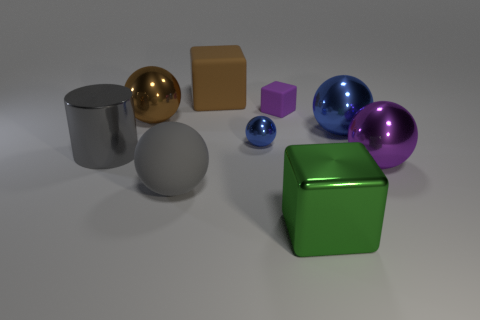What is the color of the block that is both to the right of the tiny blue object and behind the green block?
Keep it short and to the point. Purple. There is a purple rubber object; how many things are left of it?
Your response must be concise. 5. What material is the large brown block?
Offer a very short reply. Rubber. The small thing on the left side of the purple thing behind the big metallic thing that is on the left side of the brown metal sphere is what color?
Make the answer very short. Blue. How many gray balls are the same size as the brown rubber thing?
Keep it short and to the point. 1. What is the color of the tiny metal thing behind the cylinder?
Keep it short and to the point. Blue. How many other things are there of the same size as the gray cylinder?
Your answer should be compact. 6. What is the size of the block that is both behind the gray cylinder and right of the tiny blue ball?
Keep it short and to the point. Small. There is a big matte cube; is it the same color as the shiny sphere left of the gray ball?
Offer a terse response. Yes. Is there a big gray matte thing that has the same shape as the large purple metallic object?
Make the answer very short. Yes. 